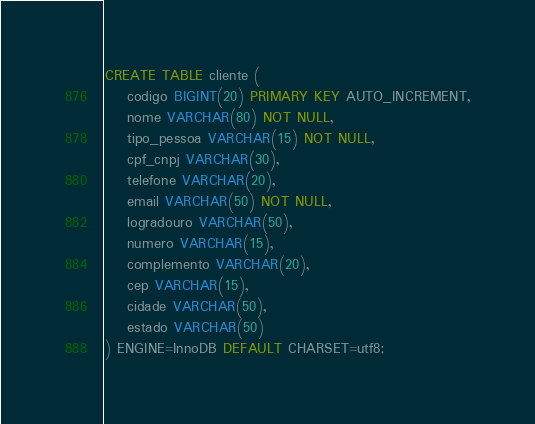<code> <loc_0><loc_0><loc_500><loc_500><_SQL_>CREATE TABLE cliente (
    codigo BIGINT(20) PRIMARY KEY AUTO_INCREMENT,
    nome VARCHAR(80) NOT NULL,
    tipo_pessoa VARCHAR(15) NOT NULL,
    cpf_cnpj VARCHAR(30),
    telefone VARCHAR(20),
    email VARCHAR(50) NOT NULL,
    logradouro VARCHAR(50),
    numero VARCHAR(15),
    complemento VARCHAR(20),
    cep VARCHAR(15),
    cidade VARCHAR(50),
    estado VARCHAR(50)
) ENGINE=InnoDB DEFAULT CHARSET=utf8;</code> 